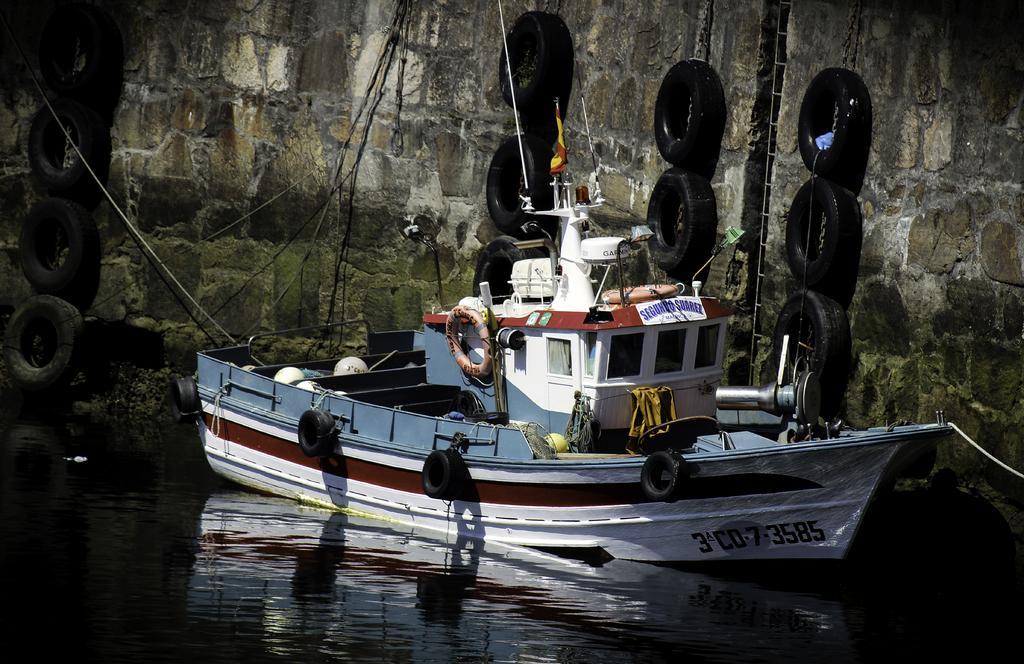Can you describe this image briefly? At the bottom there is a water body. In the middle there is a boat. At the top we can see tyres and wall. 